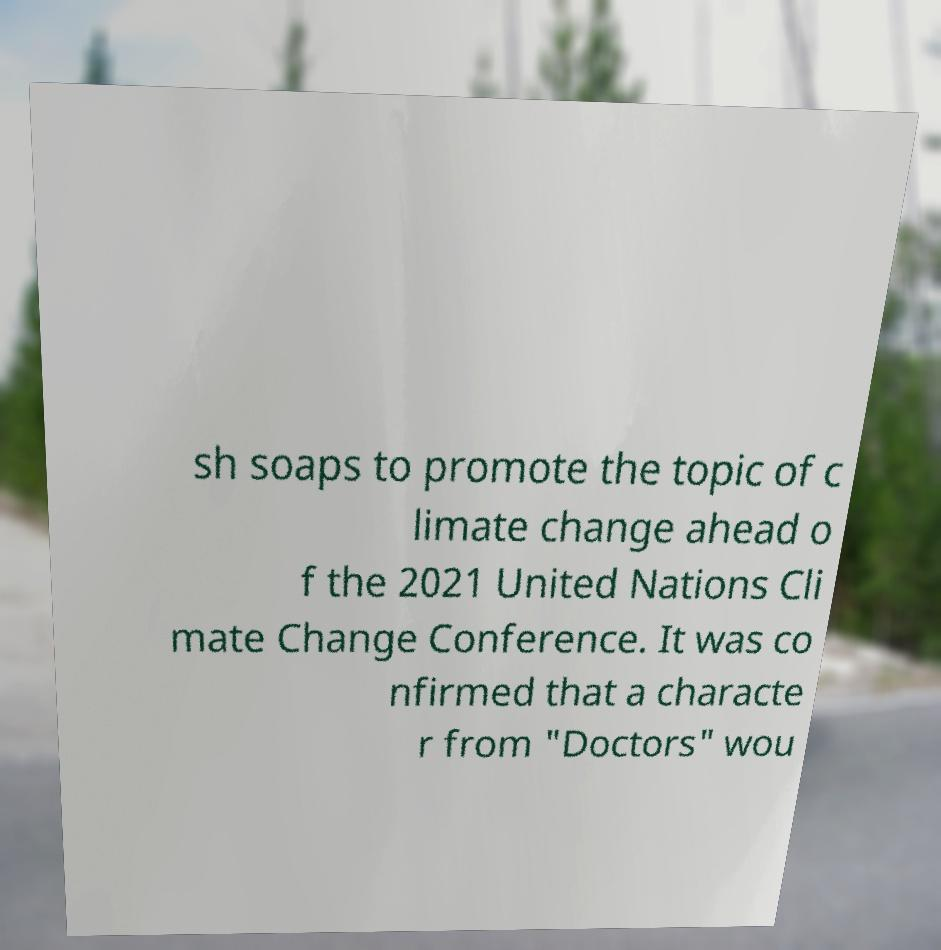Please read and relay the text visible in this image. What does it say? sh soaps to promote the topic of c limate change ahead o f the 2021 United Nations Cli mate Change Conference. It was co nfirmed that a characte r from "Doctors" wou 